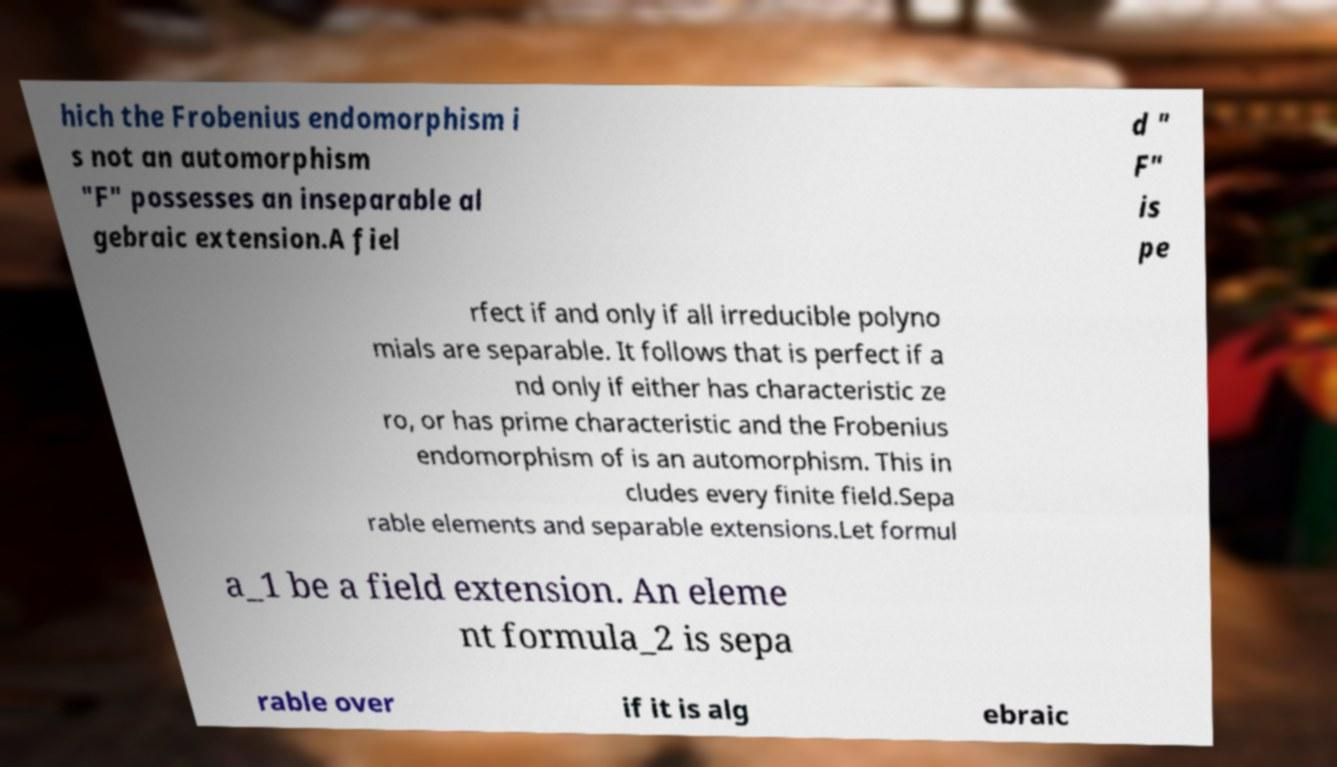What messages or text are displayed in this image? I need them in a readable, typed format. hich the Frobenius endomorphism i s not an automorphism "F" possesses an inseparable al gebraic extension.A fiel d " F" is pe rfect if and only if all irreducible polyno mials are separable. It follows that is perfect if a nd only if either has characteristic ze ro, or has prime characteristic and the Frobenius endomorphism of is an automorphism. This in cludes every finite field.Sepa rable elements and separable extensions.Let formul a_1 be a field extension. An eleme nt formula_2 is sepa rable over if it is alg ebraic 